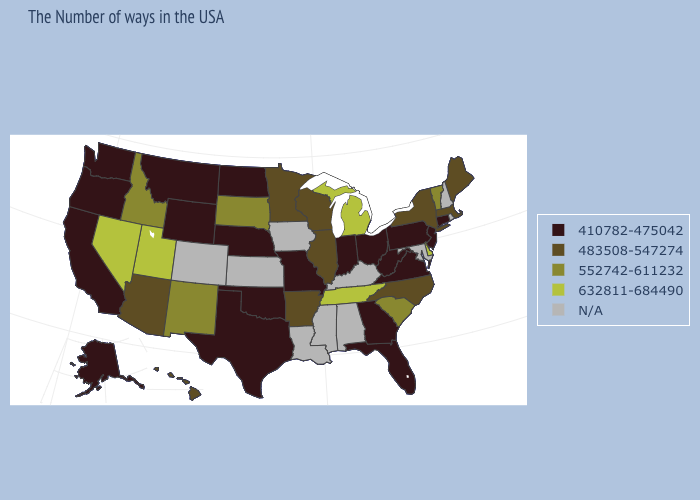What is the value of Nebraska?
Write a very short answer. 410782-475042. Among the states that border South Carolina , which have the highest value?
Short answer required. North Carolina. Name the states that have a value in the range 632811-684490?
Concise answer only. Delaware, Michigan, Tennessee, Utah, Nevada. Does the first symbol in the legend represent the smallest category?
Write a very short answer. Yes. Name the states that have a value in the range 410782-475042?
Answer briefly. Connecticut, New Jersey, Pennsylvania, Virginia, West Virginia, Ohio, Florida, Georgia, Indiana, Missouri, Nebraska, Oklahoma, Texas, North Dakota, Wyoming, Montana, California, Washington, Oregon, Alaska. Name the states that have a value in the range N/A?
Answer briefly. Rhode Island, New Hampshire, Maryland, Kentucky, Alabama, Mississippi, Louisiana, Iowa, Kansas, Colorado. Does North Carolina have the highest value in the USA?
Answer briefly. No. Does the map have missing data?
Keep it brief. Yes. What is the value of Georgia?
Write a very short answer. 410782-475042. Does Vermont have the highest value in the Northeast?
Be succinct. Yes. Name the states that have a value in the range 410782-475042?
Short answer required. Connecticut, New Jersey, Pennsylvania, Virginia, West Virginia, Ohio, Florida, Georgia, Indiana, Missouri, Nebraska, Oklahoma, Texas, North Dakota, Wyoming, Montana, California, Washington, Oregon, Alaska. Name the states that have a value in the range 552742-611232?
Concise answer only. Vermont, South Carolina, South Dakota, New Mexico, Idaho. Name the states that have a value in the range 483508-547274?
Concise answer only. Maine, Massachusetts, New York, North Carolina, Wisconsin, Illinois, Arkansas, Minnesota, Arizona, Hawaii. 